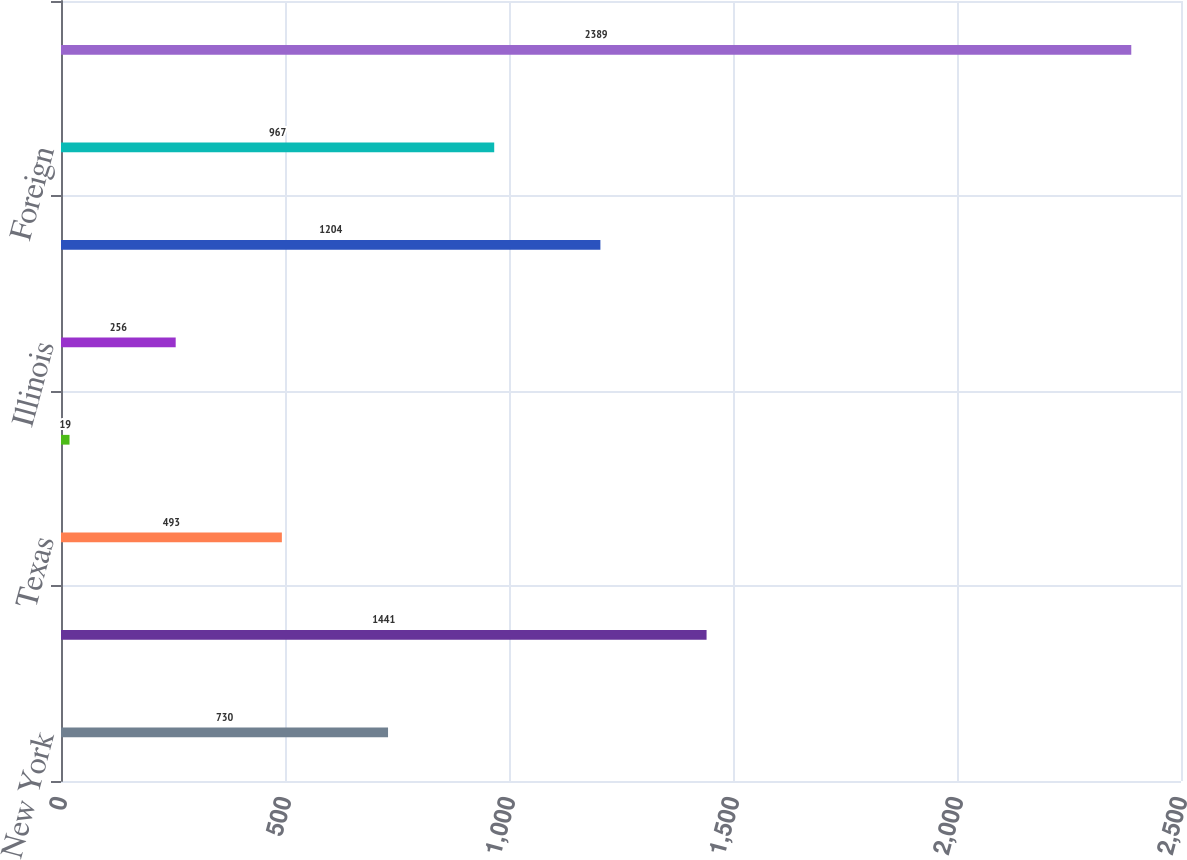<chart> <loc_0><loc_0><loc_500><loc_500><bar_chart><fcel>New York<fcel>California<fcel>Texas<fcel>Florida<fcel>Illinois<fcel>Other states<fcel>Foreign<fcel>Total<nl><fcel>730<fcel>1441<fcel>493<fcel>19<fcel>256<fcel>1204<fcel>967<fcel>2389<nl></chart> 